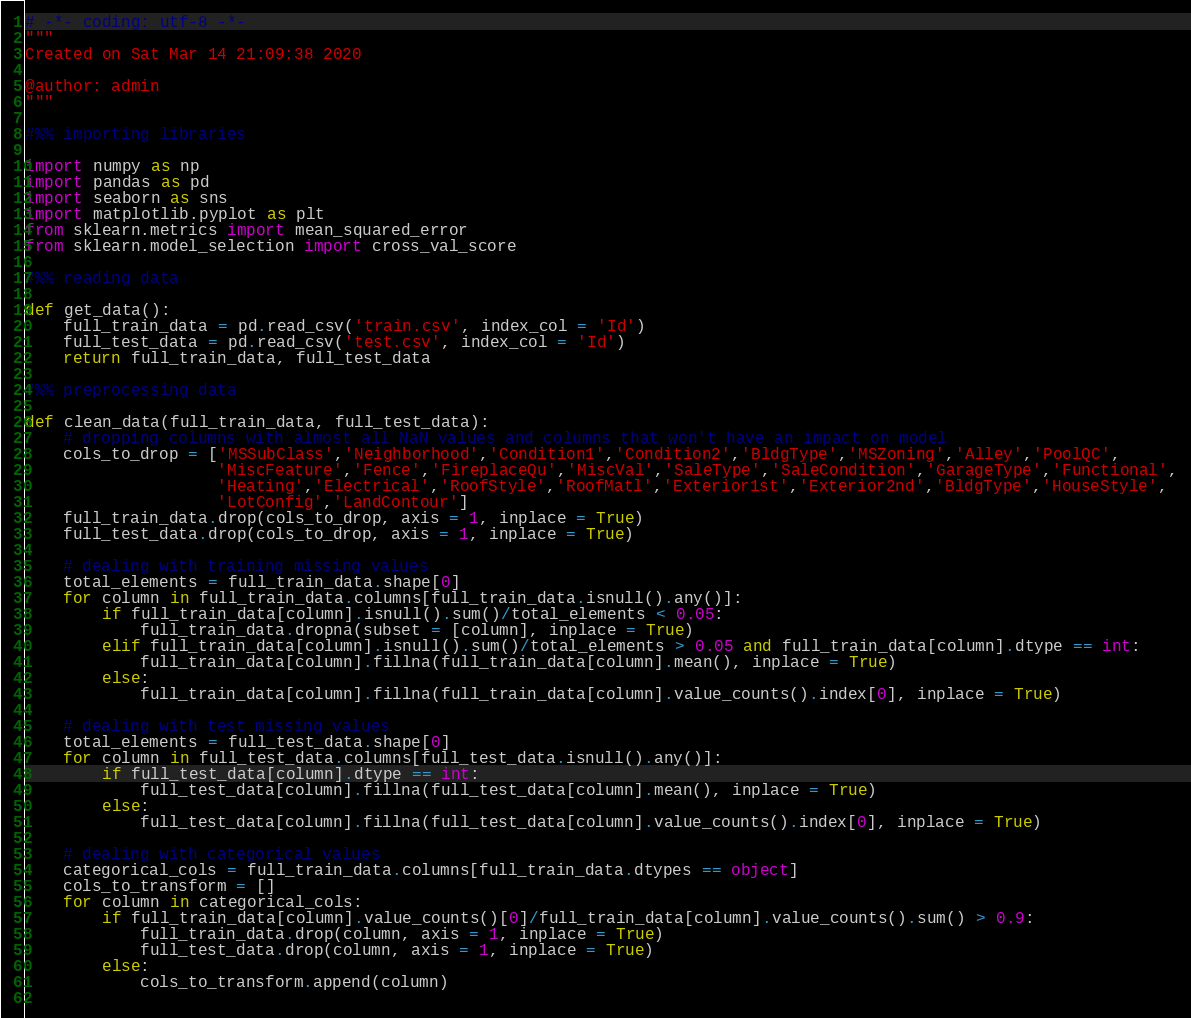<code> <loc_0><loc_0><loc_500><loc_500><_Python_># -*- coding: utf-8 -*-
"""
Created on Sat Mar 14 21:09:38 2020

@author: admin
"""

#%% importing libraries

import numpy as np
import pandas as pd
import seaborn as sns
import matplotlib.pyplot as plt
from sklearn.metrics import mean_squared_error
from sklearn.model_selection import cross_val_score

#%% reading data

def get_data():
    full_train_data = pd.read_csv('train.csv', index_col = 'Id')
    full_test_data = pd.read_csv('test.csv', index_col = 'Id')
    return full_train_data, full_test_data

#%% preprocessing data
    
def clean_data(full_train_data, full_test_data):
    # dropping columns with almost all NaN values and columns that won't have an impact on model
    cols_to_drop = ['MSSubClass','Neighborhood','Condition1','Condition2','BldgType','MSZoning','Alley','PoolQC',
                    'MiscFeature','Fence','FireplaceQu','MiscVal','SaleType','SaleCondition','GarageType','Functional',
                    'Heating','Electrical','RoofStyle','RoofMatl','Exterior1st','Exterior2nd','BldgType','HouseStyle',
                    'LotConfig','LandContour']
    full_train_data.drop(cols_to_drop, axis = 1, inplace = True)
    full_test_data.drop(cols_to_drop, axis = 1, inplace = True)
    
    # dealing with training missing values
    total_elements = full_train_data.shape[0]
    for column in full_train_data.columns[full_train_data.isnull().any()]:
        if full_train_data[column].isnull().sum()/total_elements < 0.05:
            full_train_data.dropna(subset = [column], inplace = True)
        elif full_train_data[column].isnull().sum()/total_elements > 0.05 and full_train_data[column].dtype == int:
            full_train_data[column].fillna(full_train_data[column].mean(), inplace = True)
        else:
            full_train_data[column].fillna(full_train_data[column].value_counts().index[0], inplace = True)
    
    # dealing with test missing values
    total_elements = full_test_data.shape[0]
    for column in full_test_data.columns[full_test_data.isnull().any()]:
        if full_test_data[column].dtype == int:
            full_test_data[column].fillna(full_test_data[column].mean(), inplace = True)
        else:
            full_test_data[column].fillna(full_test_data[column].value_counts().index[0], inplace = True)
            
    # dealing with categorical values
    categorical_cols = full_train_data.columns[full_train_data.dtypes == object]
    cols_to_transform = []
    for column in categorical_cols:
        if full_train_data[column].value_counts()[0]/full_train_data[column].value_counts().sum() > 0.9:
            full_train_data.drop(column, axis = 1, inplace = True)
            full_test_data.drop(column, axis = 1, inplace = True)          
        else:
            cols_to_transform.append(column)
    </code> 